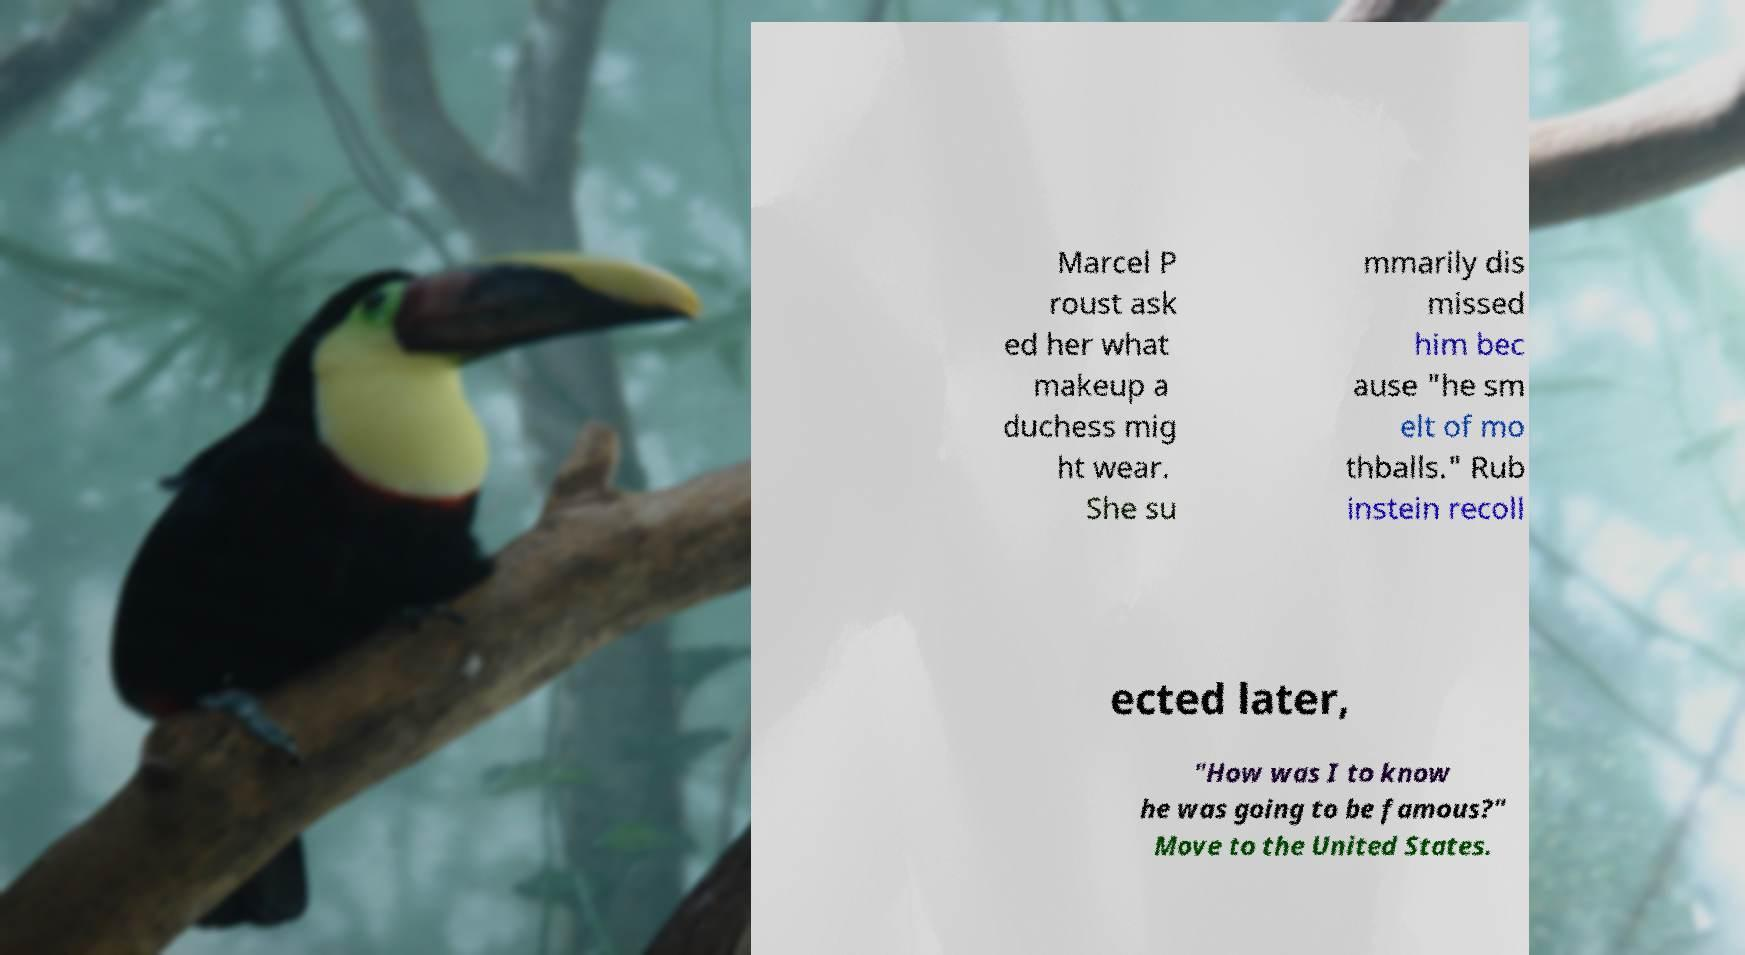I need the written content from this picture converted into text. Can you do that? Marcel P roust ask ed her what makeup a duchess mig ht wear. She su mmarily dis missed him bec ause "he sm elt of mo thballs." Rub instein recoll ected later, "How was I to know he was going to be famous?" Move to the United States. 